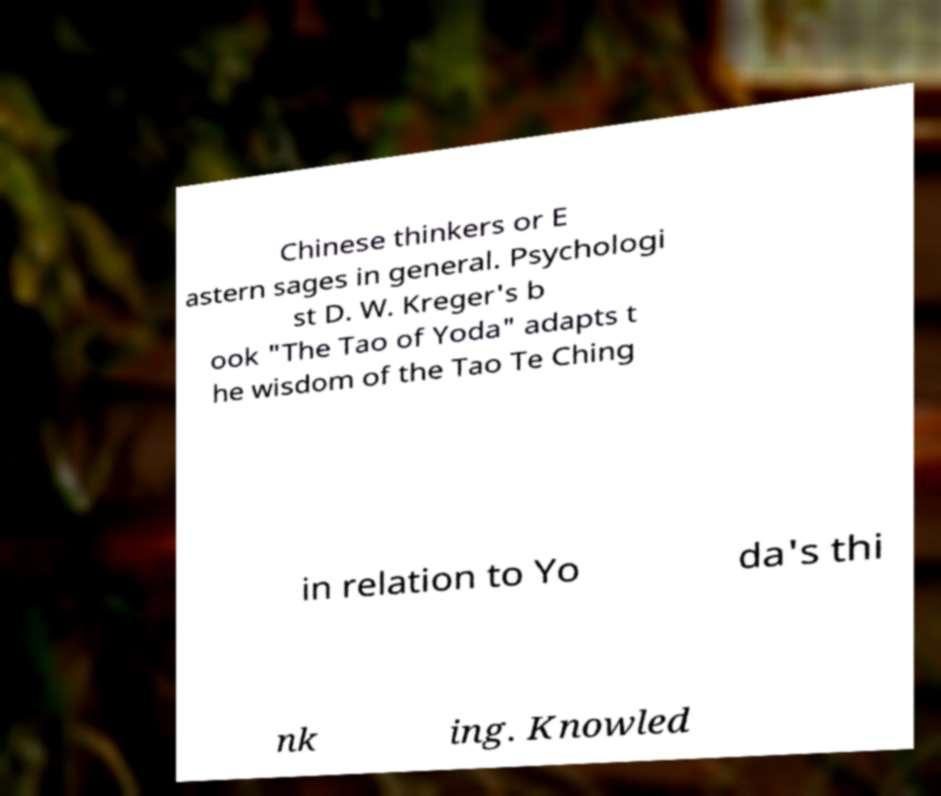Please read and relay the text visible in this image. What does it say? Chinese thinkers or E astern sages in general. Psychologi st D. W. Kreger's b ook "The Tao of Yoda" adapts t he wisdom of the Tao Te Ching in relation to Yo da's thi nk ing. Knowled 